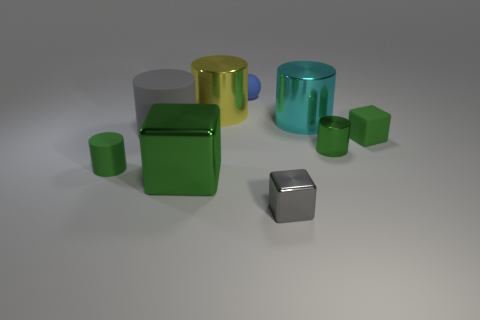Which object in the image looks the heaviest and why? The object that appears the heaviest in the image is the large blue cylinder on the right. Its size relative to the other objects suggests a greater volume and, assuming the same material density, likely a heavier weight as well. 